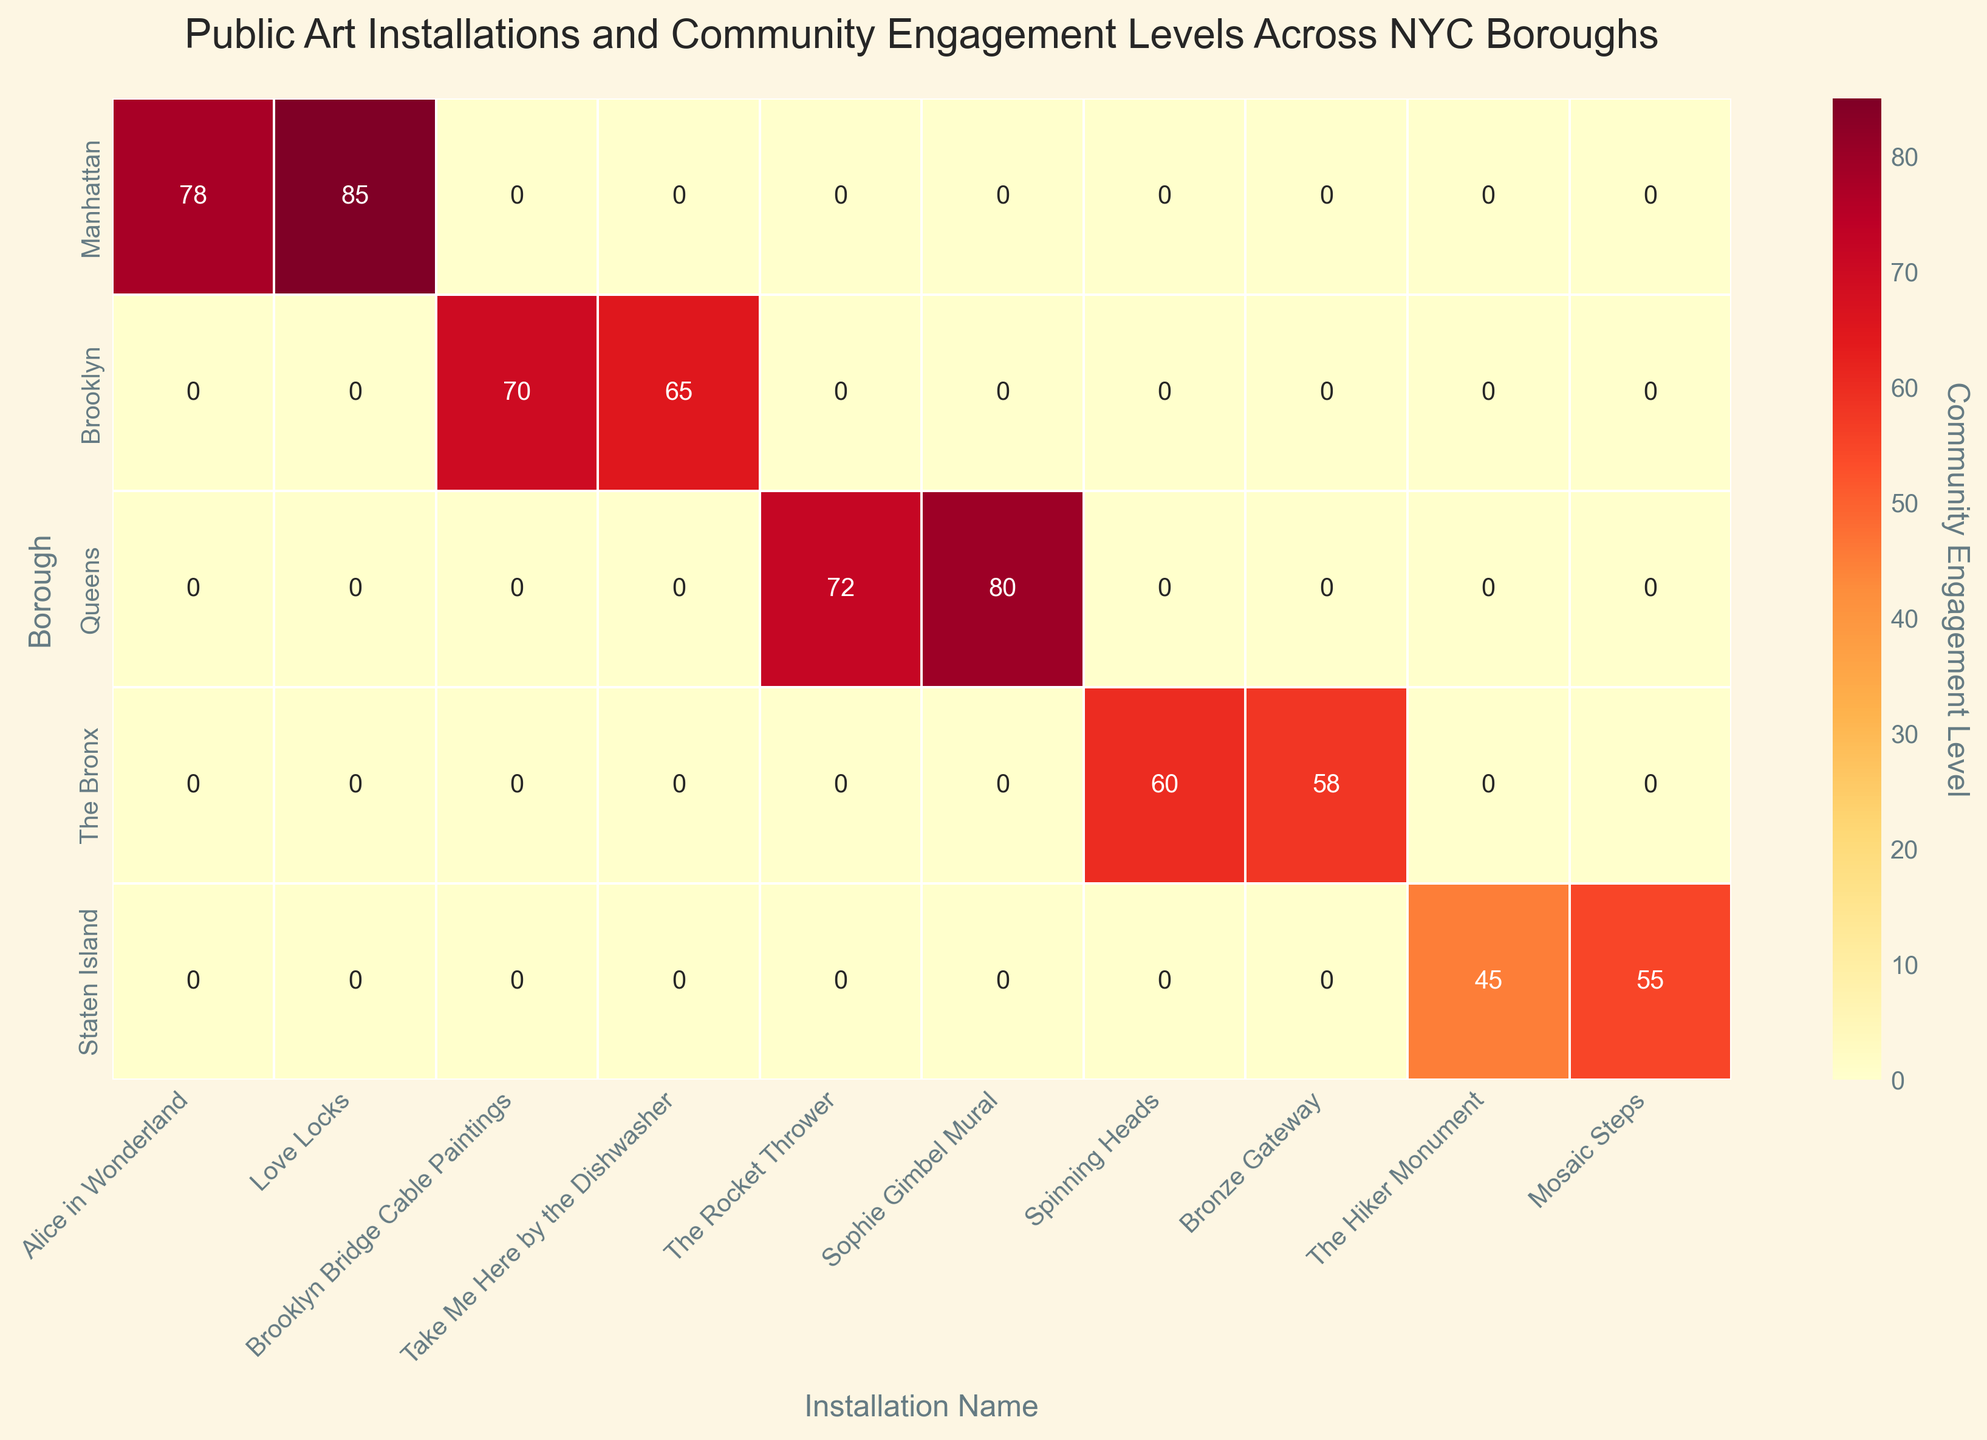Which NYC borough has the highest community engagement level for a public art installation? Look for the highest value in the heatmap and note the borough and installation. Manhattan with "Love Locks" shows 85, the highest engagement level.
Answer: Manhattan Which public art installation in Queens had the highest community engagement level? Identify the values in the heatmap for installations in Queens. "Sophie Gimbel Mural" has the highest engagement level of 80.
Answer: Sophie Gimbel Mural What is the range of community engagement levels for public art installations in The Bronx? Locate the values for installations in The Bronx and calculate the difference between the highest and lowest values. The values are 60 and 58, so the range is 60 - 58.
Answer: 2 In which borough is the "The Hiker Monument" located and what is its community engagement level? Find "The Hiker Monument" on the figure and read its corresponding borough and engagement level. It is located in Staten Island with an engagement level of 45.
Answer: Staten Island, 45 Which borough has the most uniformly high community engagement levels across its installations? Compare the heatmap values across each borough. Manhattan generally has higher and more uniform engagement levels with values of 78 and 85.
Answer: Manhattan What is the total community engagement level for all installations in Brooklyn? Add all the engagement levels for Brooklyn installations. 70 (Brooklyn Bridge Cable Paintings) + 65 (Take Me Here by the Dishwasher) = 135.
Answer: 135 How does the community engagement for "Alice in Wonderland" compare to "The Rocket Thrower" in terms of value? Compare the specific engagement levels directly from the heatmap. "Alice in Wonderland" has 78 and "The Rocket Thrower" has 72, so "Alice in Wonderland" has a higher engagement level.
Answer: Alice in Wonderland is higher What is the average community engagement level for public art installations in Queens? Sum the engagement levels for all installations in Queens and divide by the number of installations. (72 + 80)/2 = 152/2 = 76.
Answer: 76 Which installation by Nina de Creeft Ward has been shown on the heatmap and what is its engagement level? Identify Nina de Creeft Ward's work on the heatmap and read the engagement level. "Sophie Gimbel Mural" with an engagement level of 80.
Answer: Sophie Gimbel Mural, 80 Which borough has the lowest average community engagement level for its installations? Calculate the average engagement levels for each borough and identify the lowest. Staten Island has 45 and 55, so the average is (45+55)/2 = 50.
Answer: Staten Island 